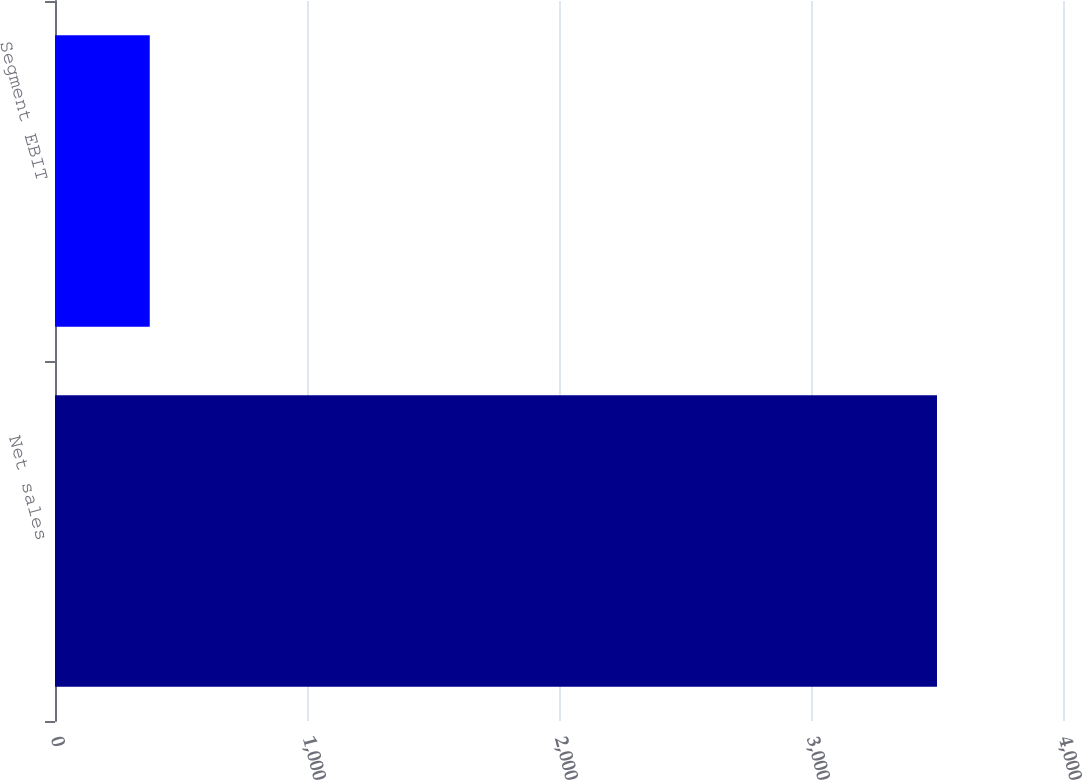<chart> <loc_0><loc_0><loc_500><loc_500><bar_chart><fcel>Net sales<fcel>Segment EBIT<nl><fcel>3500<fcel>376<nl></chart> 